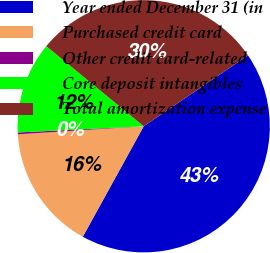Convert chart. <chart><loc_0><loc_0><loc_500><loc_500><pie_chart><fcel>Year ended December 31 (in<fcel>Purchased credit card<fcel>Other credit card-related<fcel>Core deposit intangibles<fcel>Total amortization expense<nl><fcel>42.52%<fcel>15.97%<fcel>0.23%<fcel>11.74%<fcel>29.54%<nl></chart> 